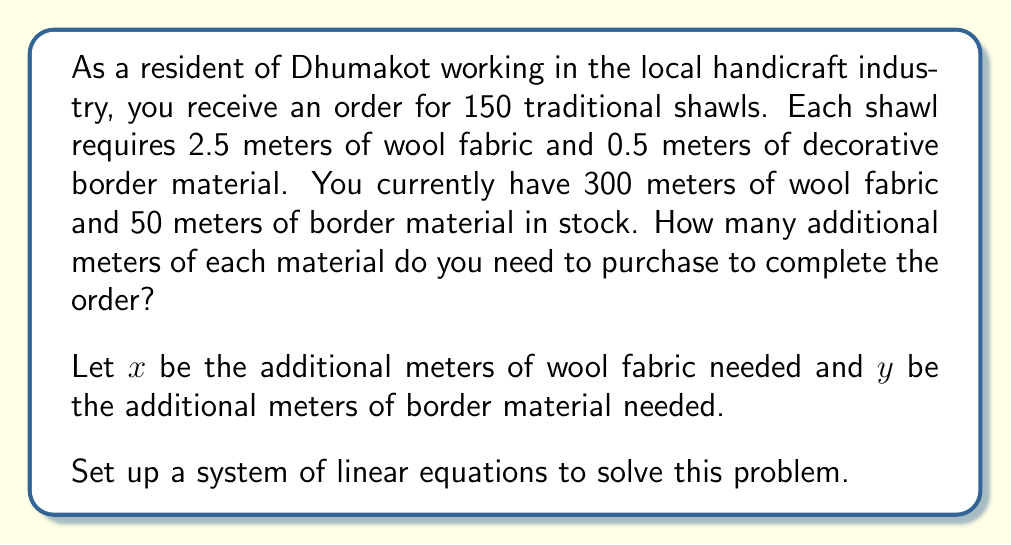Help me with this question. To solve this problem, we need to set up and solve a system of linear equations:

1. For the wool fabric:
   $$300 + x = 150 \cdot 2.5$$

2. For the border material:
   $$50 + y = 150 \cdot 0.5$$

Let's solve each equation:

1. Wool fabric equation:
   $$300 + x = 150 \cdot 2.5$$
   $$300 + x = 375$$
   $$x = 375 - 300$$
   $$x = 75$$

2. Border material equation:
   $$50 + y = 150 \cdot 0.5$$
   $$50 + y = 75$$
   $$y = 75 - 50$$
   $$y = 25$$

Therefore, you need to purchase an additional 75 meters of wool fabric and 25 meters of border material.
Answer: Additional wool fabric needed: 75 meters
Additional border material needed: 25 meters 